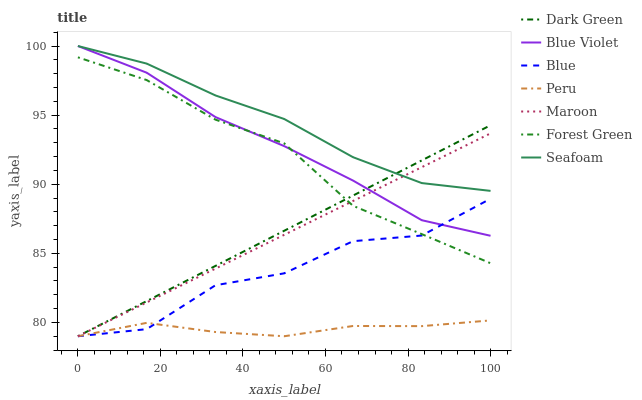Does Peru have the minimum area under the curve?
Answer yes or no. Yes. Does Seafoam have the maximum area under the curve?
Answer yes or no. Yes. Does Maroon have the minimum area under the curve?
Answer yes or no. No. Does Maroon have the maximum area under the curve?
Answer yes or no. No. Is Maroon the smoothest?
Answer yes or no. Yes. Is Blue the roughest?
Answer yes or no. Yes. Is Seafoam the smoothest?
Answer yes or no. No. Is Seafoam the roughest?
Answer yes or no. No. Does Blue have the lowest value?
Answer yes or no. Yes. Does Seafoam have the lowest value?
Answer yes or no. No. Does Blue Violet have the highest value?
Answer yes or no. Yes. Does Maroon have the highest value?
Answer yes or no. No. Is Peru less than Blue Violet?
Answer yes or no. Yes. Is Blue Violet greater than Peru?
Answer yes or no. Yes. Does Dark Green intersect Peru?
Answer yes or no. Yes. Is Dark Green less than Peru?
Answer yes or no. No. Is Dark Green greater than Peru?
Answer yes or no. No. Does Peru intersect Blue Violet?
Answer yes or no. No. 